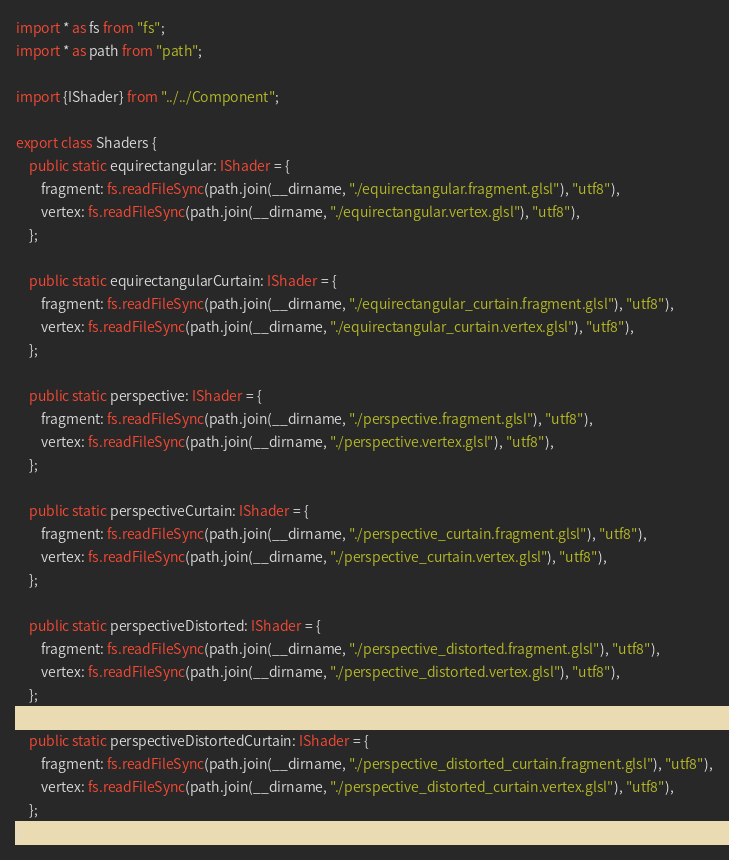<code> <loc_0><loc_0><loc_500><loc_500><_TypeScript_>import * as fs from "fs";
import * as path from "path";

import {IShader} from "../../Component";

export class Shaders {
    public static equirectangular: IShader = {
        fragment: fs.readFileSync(path.join(__dirname, "./equirectangular.fragment.glsl"), "utf8"),
        vertex: fs.readFileSync(path.join(__dirname, "./equirectangular.vertex.glsl"), "utf8"),
    };

    public static equirectangularCurtain: IShader = {
        fragment: fs.readFileSync(path.join(__dirname, "./equirectangular_curtain.fragment.glsl"), "utf8"),
        vertex: fs.readFileSync(path.join(__dirname, "./equirectangular_curtain.vertex.glsl"), "utf8"),
    };

    public static perspective: IShader = {
        fragment: fs.readFileSync(path.join(__dirname, "./perspective.fragment.glsl"), "utf8"),
        vertex: fs.readFileSync(path.join(__dirname, "./perspective.vertex.glsl"), "utf8"),
    };

    public static perspectiveCurtain: IShader = {
        fragment: fs.readFileSync(path.join(__dirname, "./perspective_curtain.fragment.glsl"), "utf8"),
        vertex: fs.readFileSync(path.join(__dirname, "./perspective_curtain.vertex.glsl"), "utf8"),
    };

    public static perspectiveDistorted: IShader = {
        fragment: fs.readFileSync(path.join(__dirname, "./perspective_distorted.fragment.glsl"), "utf8"),
        vertex: fs.readFileSync(path.join(__dirname, "./perspective_distorted.vertex.glsl"), "utf8"),
    };

    public static perspectiveDistortedCurtain: IShader = {
        fragment: fs.readFileSync(path.join(__dirname, "./perspective_distorted_curtain.fragment.glsl"), "utf8"),
        vertex: fs.readFileSync(path.join(__dirname, "./perspective_distorted_curtain.vertex.glsl"), "utf8"),
    };
}
</code> 